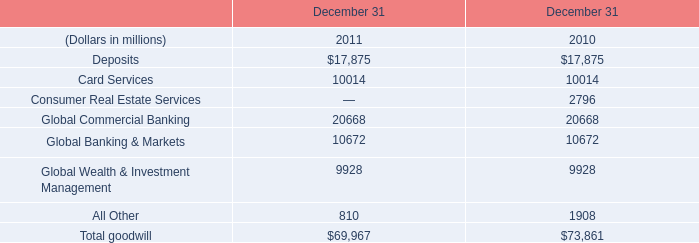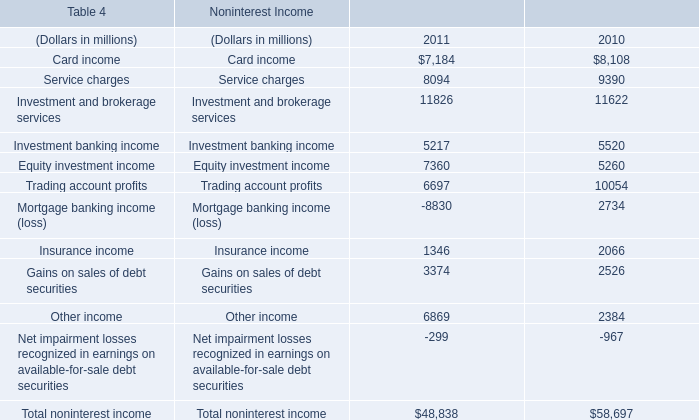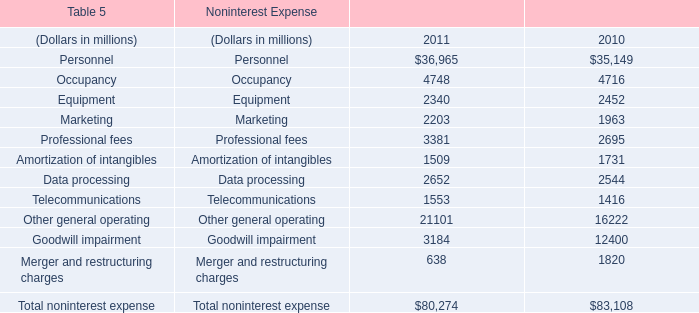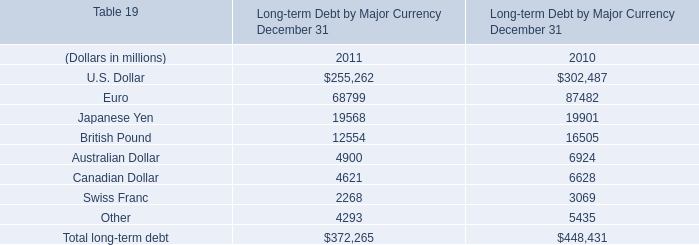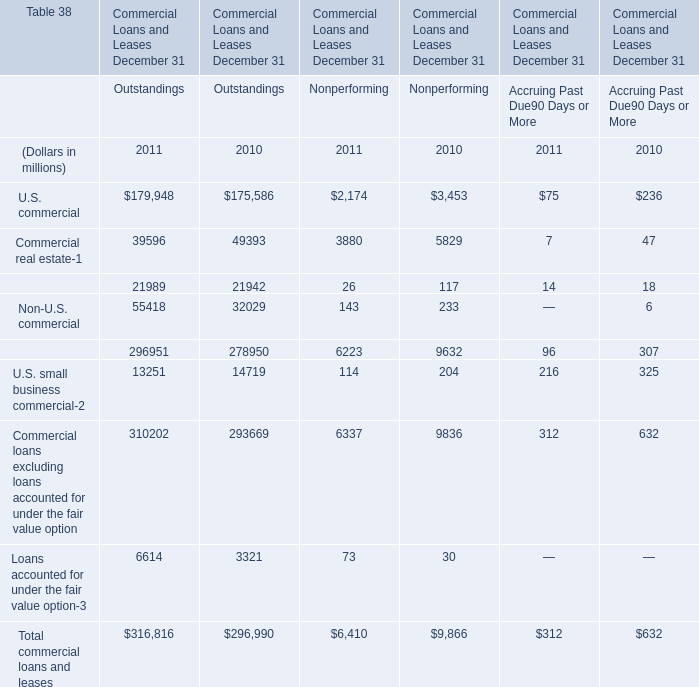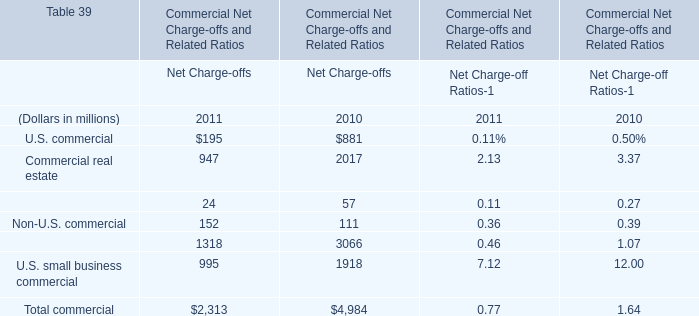What is the sum of Occupancy of Noninterest Expense 2011, and Gains on sales of debt securities of Noninterest Income 2010 ? 
Computations: (4748.0 + 2526.0)
Answer: 7274.0. 